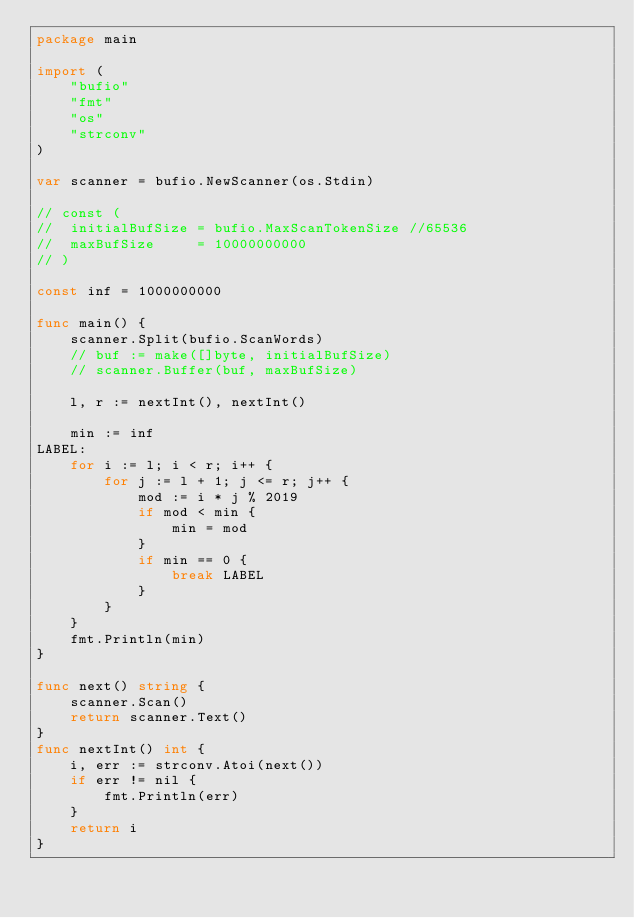<code> <loc_0><loc_0><loc_500><loc_500><_Go_>package main

import (
	"bufio"
	"fmt"
	"os"
	"strconv"
)

var scanner = bufio.NewScanner(os.Stdin)

// const (
// 	initialBufSize = bufio.MaxScanTokenSize //65536
// 	maxBufSize     = 10000000000
// )

const inf = 1000000000

func main() {
	scanner.Split(bufio.ScanWords)
	// buf := make([]byte, initialBufSize)
	// scanner.Buffer(buf, maxBufSize)

	l, r := nextInt(), nextInt()

	min := inf
LABEL:
	for i := l; i < r; i++ {
		for j := l + 1; j <= r; j++ {
			mod := i * j % 2019
			if mod < min {
				min = mod
			}
			if min == 0 {
				break LABEL
			}
		}
	}
	fmt.Println(min)
}

func next() string {
	scanner.Scan()
	return scanner.Text()
}
func nextInt() int {
	i, err := strconv.Atoi(next())
	if err != nil {
		fmt.Println(err)
	}
	return i
}
</code> 